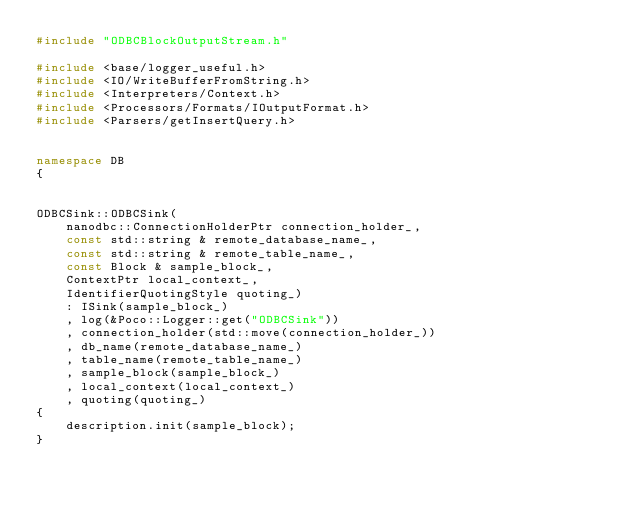Convert code to text. <code><loc_0><loc_0><loc_500><loc_500><_C++_>#include "ODBCBlockOutputStream.h"

#include <base/logger_useful.h>
#include <IO/WriteBufferFromString.h>
#include <Interpreters/Context.h>
#include <Processors/Formats/IOutputFormat.h>
#include <Parsers/getInsertQuery.h>


namespace DB
{


ODBCSink::ODBCSink(
    nanodbc::ConnectionHolderPtr connection_holder_,
    const std::string & remote_database_name_,
    const std::string & remote_table_name_,
    const Block & sample_block_,
    ContextPtr local_context_,
    IdentifierQuotingStyle quoting_)
    : ISink(sample_block_)
    , log(&Poco::Logger::get("ODBCSink"))
    , connection_holder(std::move(connection_holder_))
    , db_name(remote_database_name_)
    , table_name(remote_table_name_)
    , sample_block(sample_block_)
    , local_context(local_context_)
    , quoting(quoting_)
{
    description.init(sample_block);
}

</code> 